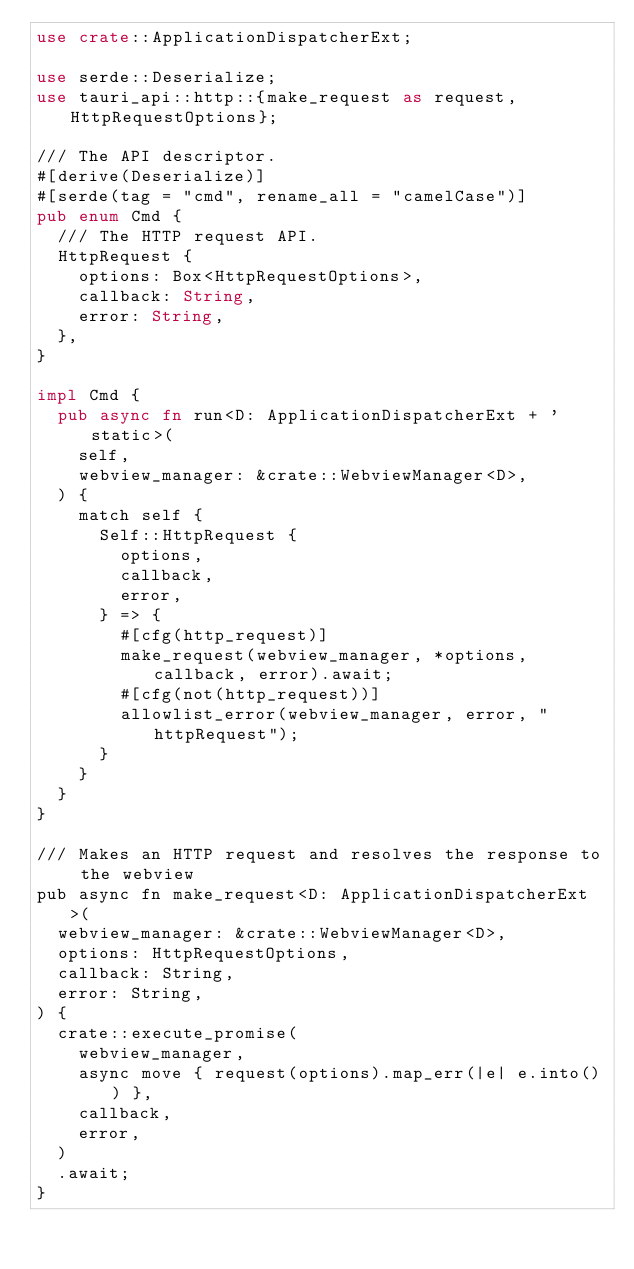<code> <loc_0><loc_0><loc_500><loc_500><_Rust_>use crate::ApplicationDispatcherExt;

use serde::Deserialize;
use tauri_api::http::{make_request as request, HttpRequestOptions};

/// The API descriptor.
#[derive(Deserialize)]
#[serde(tag = "cmd", rename_all = "camelCase")]
pub enum Cmd {
  /// The HTTP request API.
  HttpRequest {
    options: Box<HttpRequestOptions>,
    callback: String,
    error: String,
  },
}

impl Cmd {
  pub async fn run<D: ApplicationDispatcherExt + 'static>(
    self,
    webview_manager: &crate::WebviewManager<D>,
  ) {
    match self {
      Self::HttpRequest {
        options,
        callback,
        error,
      } => {
        #[cfg(http_request)]
        make_request(webview_manager, *options, callback, error).await;
        #[cfg(not(http_request))]
        allowlist_error(webview_manager, error, "httpRequest");
      }
    }
  }
}

/// Makes an HTTP request and resolves the response to the webview
pub async fn make_request<D: ApplicationDispatcherExt>(
  webview_manager: &crate::WebviewManager<D>,
  options: HttpRequestOptions,
  callback: String,
  error: String,
) {
  crate::execute_promise(
    webview_manager,
    async move { request(options).map_err(|e| e.into()) },
    callback,
    error,
  )
  .await;
}
</code> 